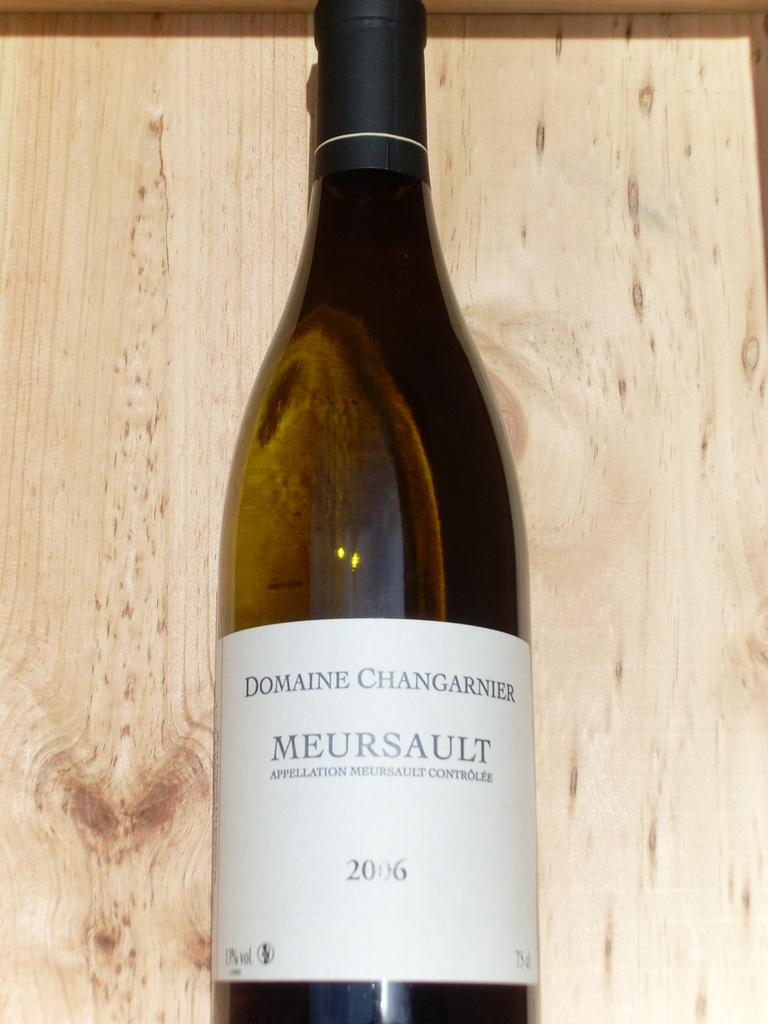<image>
Relay a brief, clear account of the picture shown. A bottle of Domaine Changarnier Meursault from 2006. 